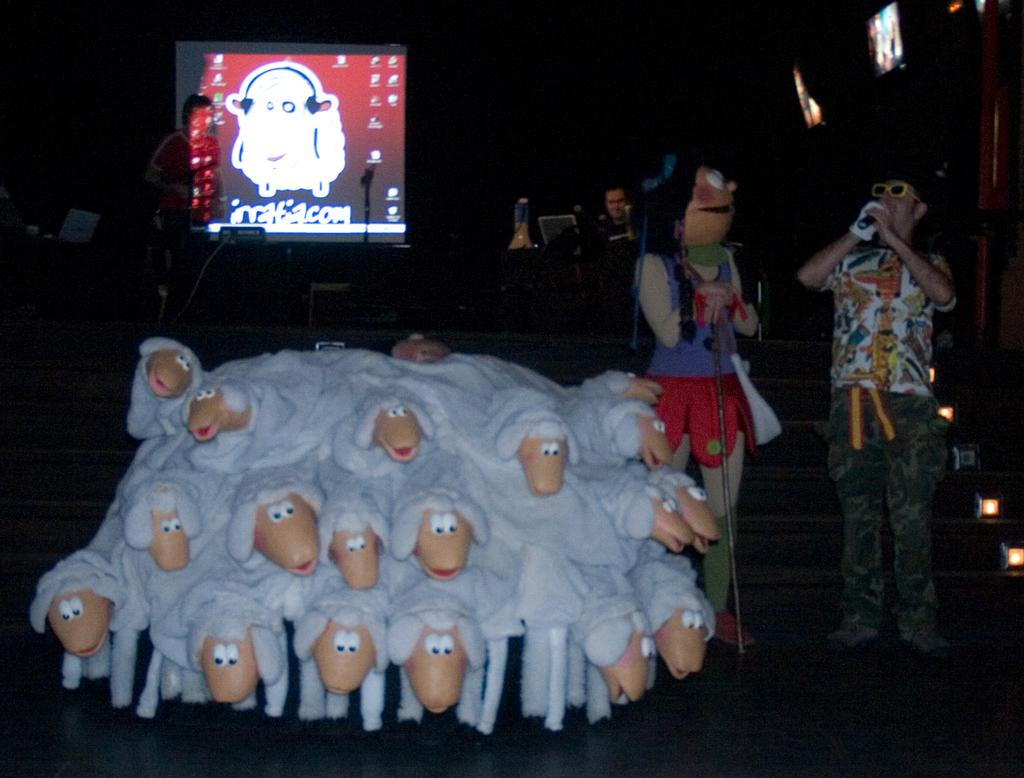What type of toys are present in the image? There are toys of sheep in the image. How many people are standing in the image? There are four persons standing in the image. Can you describe the attire of one of the persons? One person is wearing a fancy dress. What architectural feature can be seen in the image? There are stairs in the image. What type of lighting is present in the image? There are lights in the image. What type of furniture is present in the image? There are chairs in the image. What type of electronic devices are present in the image? There are screens in the image. How many eggs are being used to make the fancy dress in the image? There are no eggs mentioned or visible in the image, and the fancy dress is not described as being made of eggs. Can you tell me how many chickens are present in the image? There are no chickens present in the image. 